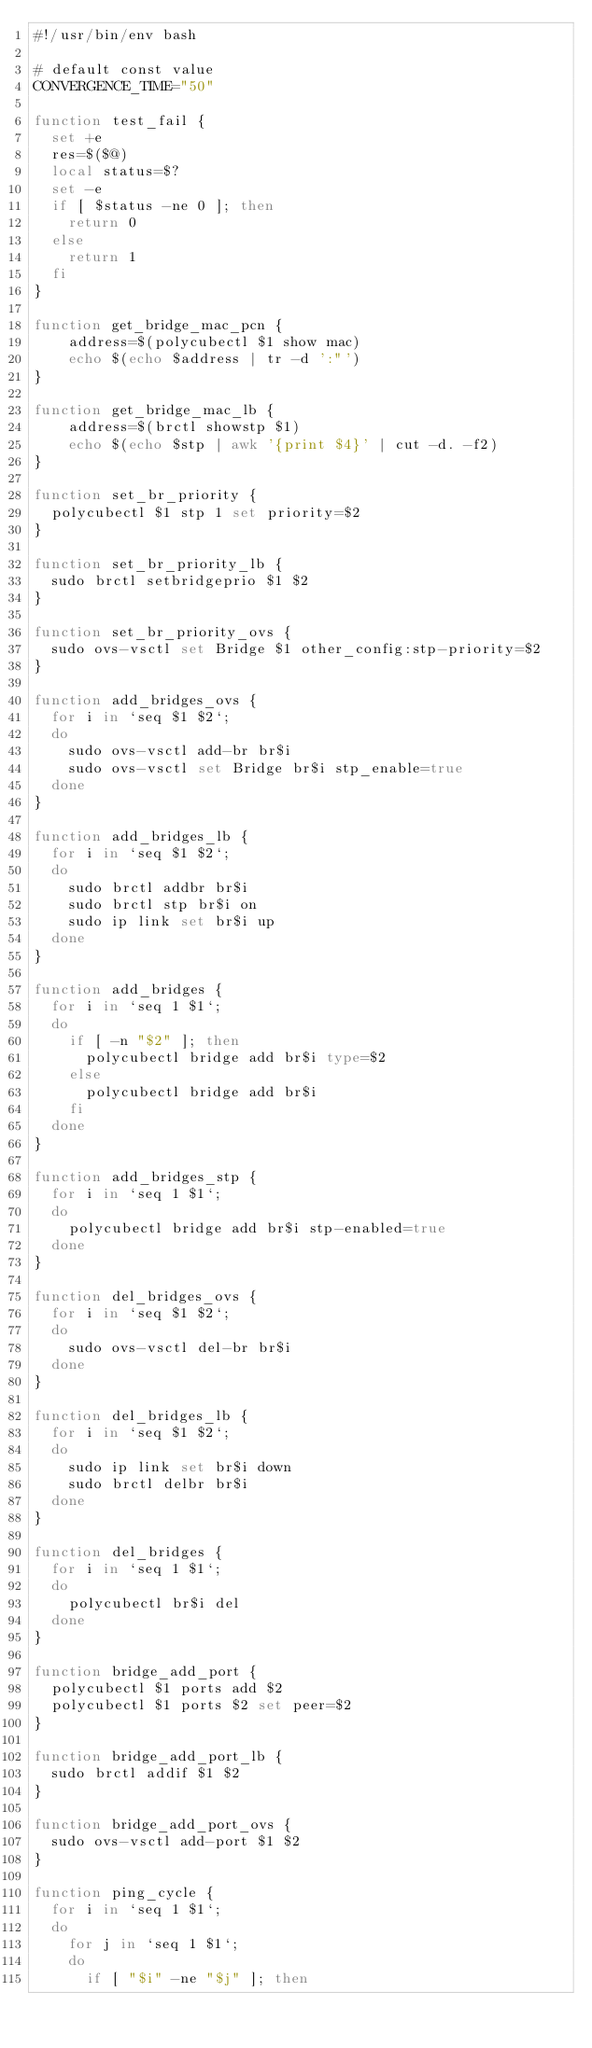<code> <loc_0><loc_0><loc_500><loc_500><_Bash_>#!/usr/bin/env bash

# default const value
CONVERGENCE_TIME="50"

function test_fail {
  set +e
  res=$($@)
  local status=$?
  set -e
  if [ $status -ne 0 ]; then
    return 0
  else
    return 1
  fi
}

function get_bridge_mac_pcn {
    address=$(polycubectl $1 show mac)
    echo $(echo $address | tr -d ':"')
}

function get_bridge_mac_lb {
    address=$(brctl showstp $1)
    echo $(echo $stp | awk '{print $4}' | cut -d. -f2)
}

function set_br_priority {
  polycubectl $1 stp 1 set priority=$2
}

function set_br_priority_lb {
  sudo brctl setbridgeprio $1 $2
}

function set_br_priority_ovs {
  sudo ovs-vsctl set Bridge $1 other_config:stp-priority=$2
}

function add_bridges_ovs {
  for i in `seq $1 $2`;
  do
    sudo ovs-vsctl add-br br$i
    sudo ovs-vsctl set Bridge br$i stp_enable=true
  done
}

function add_bridges_lb {
  for i in `seq $1 $2`;
  do
    sudo brctl addbr br$i
    sudo brctl stp br$i on
    sudo ip link set br$i up
  done
}

function add_bridges {
  for i in `seq 1 $1`;
  do
    if [ -n "$2" ]; then
      polycubectl bridge add br$i type=$2
    else
      polycubectl bridge add br$i
    fi
  done
}

function add_bridges_stp {
  for i in `seq 1 $1`;
  do
    polycubectl bridge add br$i stp-enabled=true
  done
}

function del_bridges_ovs {
  for i in `seq $1 $2`;
  do
    sudo ovs-vsctl del-br br$i
  done
}

function del_bridges_lb {
  for i in `seq $1 $2`;
  do
    sudo ip link set br$i down
    sudo brctl delbr br$i
  done
}

function del_bridges {
  for i in `seq 1 $1`;
  do
    polycubectl br$i del
  done
}

function bridge_add_port {
  polycubectl $1 ports add $2
  polycubectl $1 ports $2 set peer=$2
}

function bridge_add_port_lb {
  sudo brctl addif $1 $2
}

function bridge_add_port_ovs {
  sudo ovs-vsctl add-port $1 $2
}

function ping_cycle {
  for i in `seq 1 $1`;
  do
    for j in `seq 1 $1`;
    do
      if [ "$i" -ne "$j" ]; then</code> 